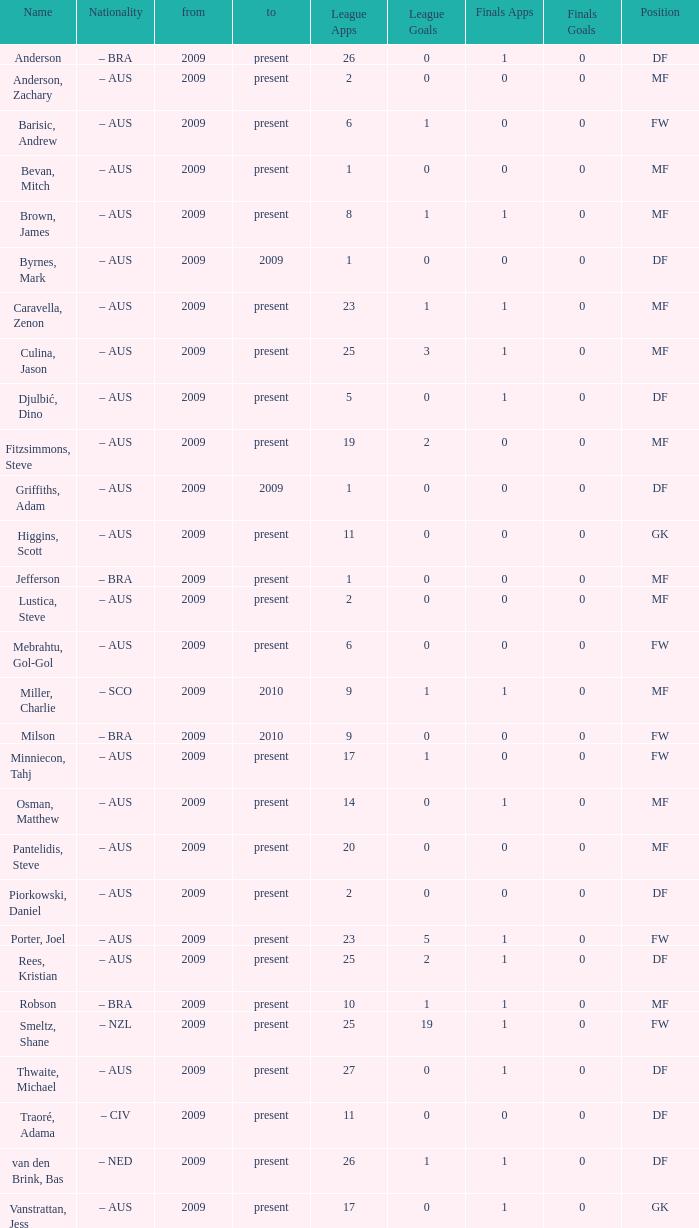Name the to for 19 league apps Present. 